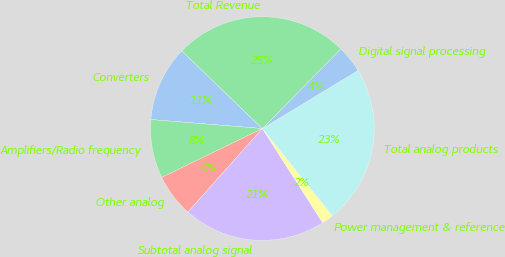Convert chart to OTSL. <chart><loc_0><loc_0><loc_500><loc_500><pie_chart><fcel>Converters<fcel>Amplifiers/Radio frequency<fcel>Other analog<fcel>Subtotal analog signal<fcel>Power management & reference<fcel>Total analog products<fcel>Digital signal processing<fcel>Total Revenue<nl><fcel>10.93%<fcel>8.48%<fcel>6.22%<fcel>20.65%<fcel>1.7%<fcel>22.91%<fcel>3.96%<fcel>25.16%<nl></chart> 